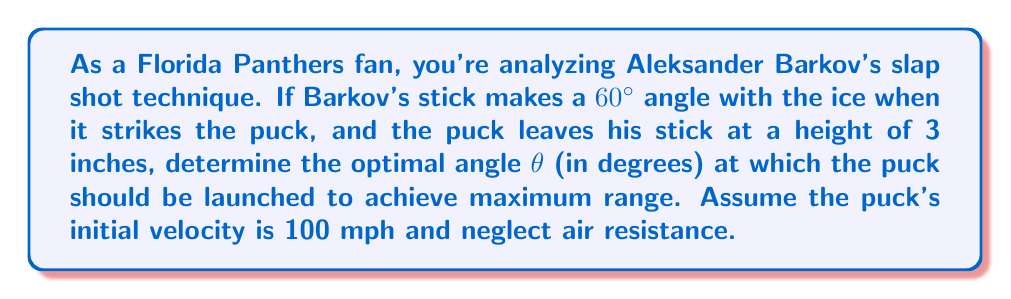Provide a solution to this math problem. Let's approach this step-by-step:

1) The optimal angle for maximum range in projectile motion, neglecting air resistance, is 45°. However, since the puck starts at a height above the ice, we need to adjust this angle.

2) The formula for the optimal angle when launching from a height h is:

   $$\theta = 45° - \frac{1}{2}\arcsin(\frac{gh}{v^2})$$

   Where g is acceleration due to gravity, h is the initial height, and v is the initial velocity.

3) We need to convert our given values to consistent units:
   - h = 3 inches = 0.0762 meters
   - v = 100 mph = 44.704 m/s
   - g = 9.81 m/s²

4) Substituting these values into our equation:

   $$\theta = 45° - \frac{1}{2}\arcsin(\frac{9.81 \times 0.0762}{44.704^2})$$

5) Simplifying:
   $$\theta = 45° - \frac{1}{2}\arcsin(0.000375)$$

6) Calculating:
   $$\theta \approx 45° - 0.0107° = 44.9893°$$

7) However, this angle is relative to the horizontal. Since Barkov's stick makes a 60° angle with the ice, we need to subtract this from our calculated angle:

   $$44.9893° - 60° = -15.0107°$$

8) The negative angle indicates that the puck should be launched 15.0107° below the line of Barkov's stick for maximum range.
Answer: -15.01° 